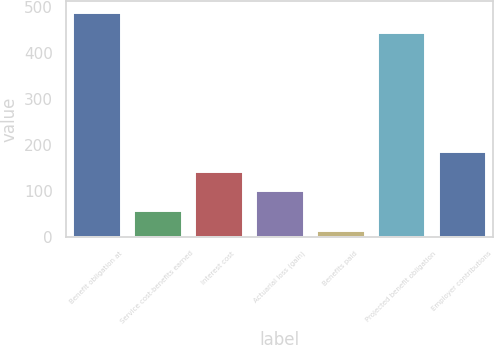Convert chart. <chart><loc_0><loc_0><loc_500><loc_500><bar_chart><fcel>Benefit obligation at<fcel>Service cost-benefits earned<fcel>Interest cost<fcel>Actuarial loss (gain)<fcel>Benefits paid<fcel>Projected benefit obligation<fcel>Employer contributions<nl><fcel>490.3<fcel>58.3<fcel>144.9<fcel>101.6<fcel>15<fcel>447<fcel>188.2<nl></chart> 